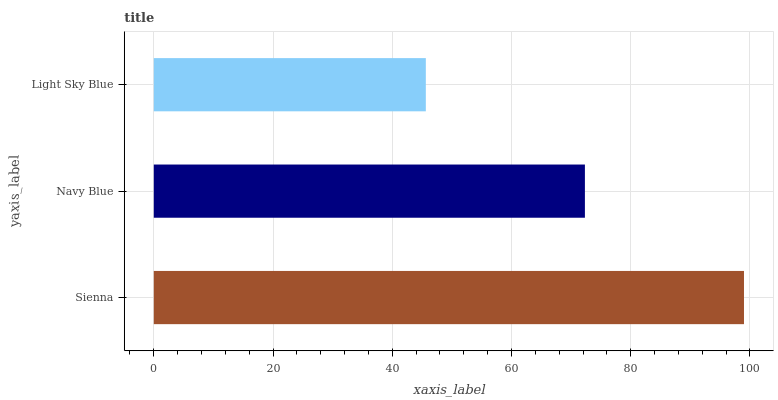Is Light Sky Blue the minimum?
Answer yes or no. Yes. Is Sienna the maximum?
Answer yes or no. Yes. Is Navy Blue the minimum?
Answer yes or no. No. Is Navy Blue the maximum?
Answer yes or no. No. Is Sienna greater than Navy Blue?
Answer yes or no. Yes. Is Navy Blue less than Sienna?
Answer yes or no. Yes. Is Navy Blue greater than Sienna?
Answer yes or no. No. Is Sienna less than Navy Blue?
Answer yes or no. No. Is Navy Blue the high median?
Answer yes or no. Yes. Is Navy Blue the low median?
Answer yes or no. Yes. Is Sienna the high median?
Answer yes or no. No. Is Light Sky Blue the low median?
Answer yes or no. No. 